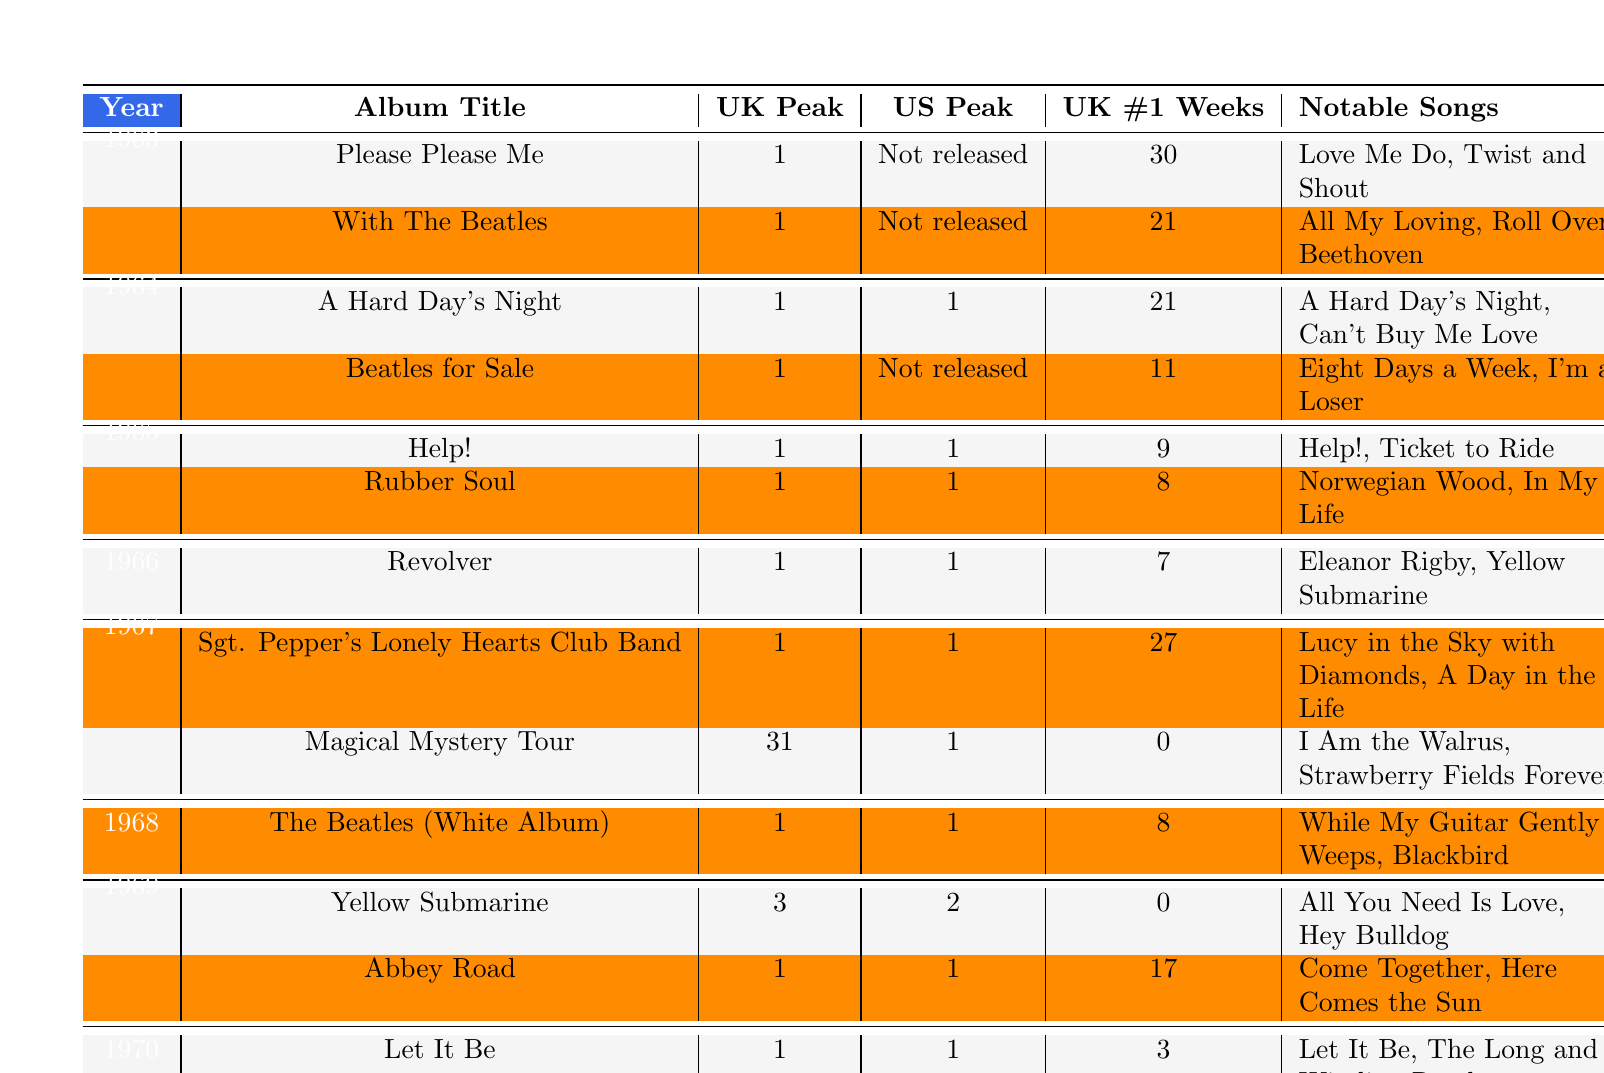What was the last album released by The Beatles? The last album listed in the timeline is "Let It Be," which was released in 1970.
Answer: Let It Be Which album had the longest duration at UK #1? The album "Please Please Me" had 30 weeks at UK #1, which is the longest duration listed in the table.
Answer: Please Please Me Did The Beatles release any albums in the US that did not reach the chart peak? Yes, the album "Beatles for Sale" was not released in the US, as indicated by the entry labeled "Not released" in the US Chart Peak column.
Answer: Yes What is the average number of weeks The Beatles spent at #1 in the UK for their albums released from 1963 to 1967? To find the average, first sum the weeks at #1: 30 + 21 + 21 + 9 + 8 + 27 = 116. Then divide by the number of albums (6): 116/6 = 19.33.
Answer: 19.33 Which album had notable songs "A Hard Day's Night" and "Can't Buy Me Love"? The album "A Hard Day's Night" is identified in the table along with those notable songs.
Answer: A Hard Day's Night How many albums released in 1964 had a UK chart peak of 1 but did not reach the US peak? In 1964, the album "Beatles for Sale" had a UK chart peak of 1 but was not released in the US, while "A Hard Day's Night" reached the US peak. Therefore, only one album meets the criteria.
Answer: 1 Which year did The Beatles achieve a US chart peak of 2 and what was the album title? The table indicates that in 1969, the album "Yellow Submarine" had a US chart peak of 2.
Answer: 1969, Yellow Submarine Were all albums from 1965 successful in both the UK and US charts? Yes, both albums, "Help!" and "Rubber Soul," achieved a UK and US chart peak of 1.
Answer: Yes What was the UK peak position of "Magical Mystery Tour"? The UK peak position for "Magical Mystery Tour" is 31.
Answer: 31 How many albums did The Beatles release in 1966? The table shows one album released in 1966: "Revolver."
Answer: 1 What notable songs are associated with the album "Sgt. Pepper's Lonely Hearts Club Band"? The notable songs listed for this album are "Lucy in the Sky with Diamonds" and "A Day in the Life."
Answer: Lucy in the Sky with Diamonds, A Day in the Life What is the total number of UK #1 weeks for albums released in 1967? For 1967, the weeks at UK #1 are 27 (Sgt. Pepper's Lonely Hearts Club Band) and 0 (Magical Mystery Tour), totaling 27 weeks.
Answer: 27 Which album has the most notable songs listed, and what are they? "Sgt. Pepper's Lonely Hearts Club Band" has two notable songs: "Lucy in the Sky with Diamonds" and "A Day in the Life."
Answer: Sgt. Pepper's Lonely Hearts Club Band; Lucy in the Sky with Diamonds, A Day in the Life What was the chart performance for "Abbey Road" in the US? "Abbey Road" achieved a US chart peak of 1, meaning it was number one in the US.
Answer: 1 